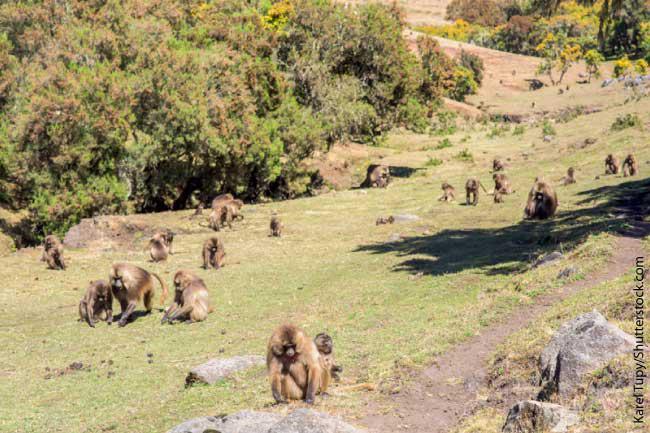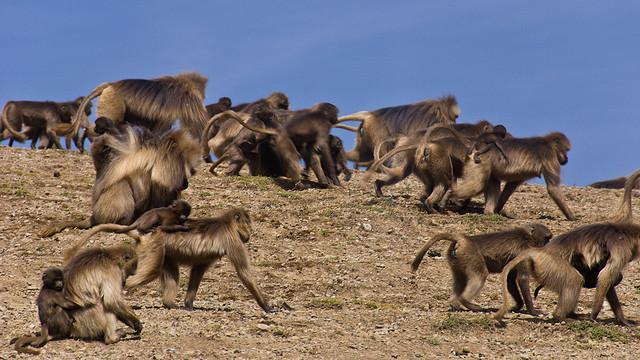The first image is the image on the left, the second image is the image on the right. Examine the images to the left and right. Is the description "An image shows baboons sitting in a green valley with many visible trees on the hillside behind them." accurate? Answer yes or no. Yes. The first image is the image on the left, the second image is the image on the right. Assess this claim about the two images: "All images feature monkeys sitting on grass.". Correct or not? Answer yes or no. No. 